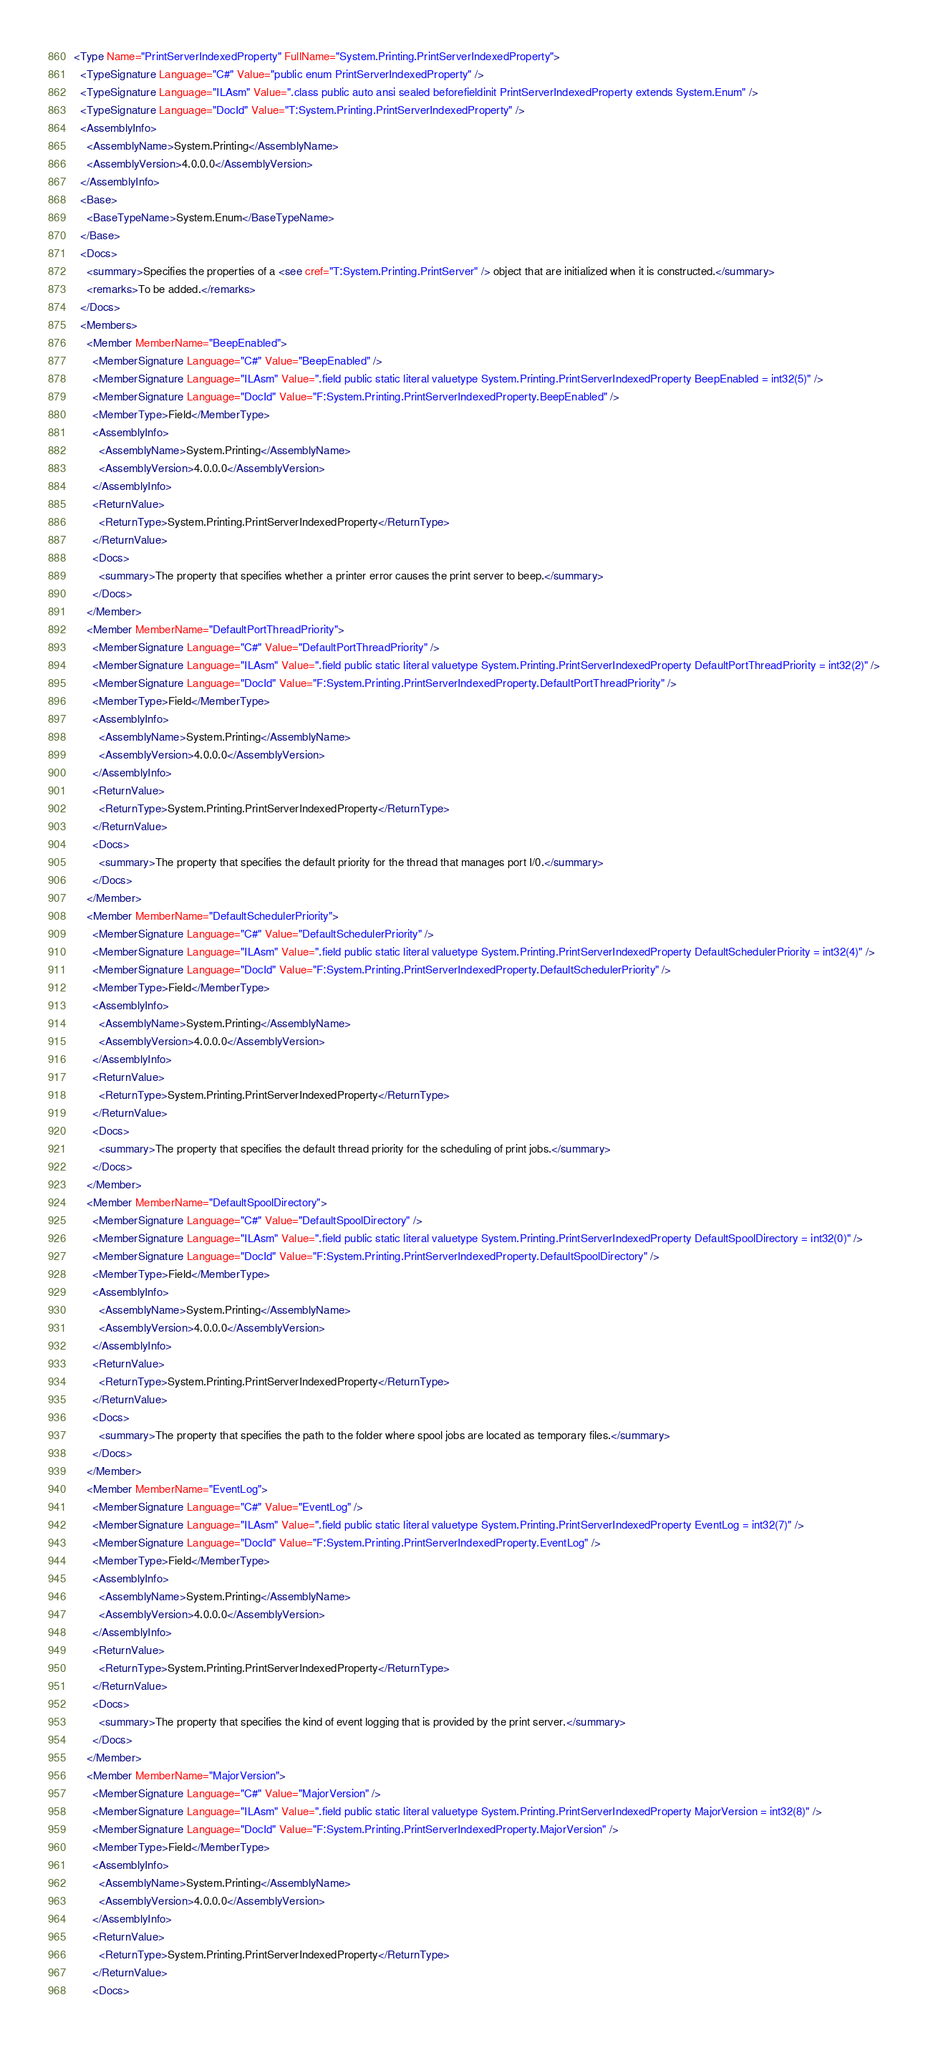Convert code to text. <code><loc_0><loc_0><loc_500><loc_500><_XML_><Type Name="PrintServerIndexedProperty" FullName="System.Printing.PrintServerIndexedProperty">
  <TypeSignature Language="C#" Value="public enum PrintServerIndexedProperty" />
  <TypeSignature Language="ILAsm" Value=".class public auto ansi sealed beforefieldinit PrintServerIndexedProperty extends System.Enum" />
  <TypeSignature Language="DocId" Value="T:System.Printing.PrintServerIndexedProperty" />
  <AssemblyInfo>
    <AssemblyName>System.Printing</AssemblyName>
    <AssemblyVersion>4.0.0.0</AssemblyVersion>
  </AssemblyInfo>
  <Base>
    <BaseTypeName>System.Enum</BaseTypeName>
  </Base>
  <Docs>
    <summary>Specifies the properties of a <see cref="T:System.Printing.PrintServer" /> object that are initialized when it is constructed.</summary>
    <remarks>To be added.</remarks>
  </Docs>
  <Members>
    <Member MemberName="BeepEnabled">
      <MemberSignature Language="C#" Value="BeepEnabled" />
      <MemberSignature Language="ILAsm" Value=".field public static literal valuetype System.Printing.PrintServerIndexedProperty BeepEnabled = int32(5)" />
      <MemberSignature Language="DocId" Value="F:System.Printing.PrintServerIndexedProperty.BeepEnabled" />
      <MemberType>Field</MemberType>
      <AssemblyInfo>
        <AssemblyName>System.Printing</AssemblyName>
        <AssemblyVersion>4.0.0.0</AssemblyVersion>
      </AssemblyInfo>
      <ReturnValue>
        <ReturnType>System.Printing.PrintServerIndexedProperty</ReturnType>
      </ReturnValue>
      <Docs>
        <summary>The property that specifies whether a printer error causes the print server to beep.</summary>
      </Docs>
    </Member>
    <Member MemberName="DefaultPortThreadPriority">
      <MemberSignature Language="C#" Value="DefaultPortThreadPriority" />
      <MemberSignature Language="ILAsm" Value=".field public static literal valuetype System.Printing.PrintServerIndexedProperty DefaultPortThreadPriority = int32(2)" />
      <MemberSignature Language="DocId" Value="F:System.Printing.PrintServerIndexedProperty.DefaultPortThreadPriority" />
      <MemberType>Field</MemberType>
      <AssemblyInfo>
        <AssemblyName>System.Printing</AssemblyName>
        <AssemblyVersion>4.0.0.0</AssemblyVersion>
      </AssemblyInfo>
      <ReturnValue>
        <ReturnType>System.Printing.PrintServerIndexedProperty</ReturnType>
      </ReturnValue>
      <Docs>
        <summary>The property that specifies the default priority for the thread that manages port I/0.</summary>
      </Docs>
    </Member>
    <Member MemberName="DefaultSchedulerPriority">
      <MemberSignature Language="C#" Value="DefaultSchedulerPriority" />
      <MemberSignature Language="ILAsm" Value=".field public static literal valuetype System.Printing.PrintServerIndexedProperty DefaultSchedulerPriority = int32(4)" />
      <MemberSignature Language="DocId" Value="F:System.Printing.PrintServerIndexedProperty.DefaultSchedulerPriority" />
      <MemberType>Field</MemberType>
      <AssemblyInfo>
        <AssemblyName>System.Printing</AssemblyName>
        <AssemblyVersion>4.0.0.0</AssemblyVersion>
      </AssemblyInfo>
      <ReturnValue>
        <ReturnType>System.Printing.PrintServerIndexedProperty</ReturnType>
      </ReturnValue>
      <Docs>
        <summary>The property that specifies the default thread priority for the scheduling of print jobs.</summary>
      </Docs>
    </Member>
    <Member MemberName="DefaultSpoolDirectory">
      <MemberSignature Language="C#" Value="DefaultSpoolDirectory" />
      <MemberSignature Language="ILAsm" Value=".field public static literal valuetype System.Printing.PrintServerIndexedProperty DefaultSpoolDirectory = int32(0)" />
      <MemberSignature Language="DocId" Value="F:System.Printing.PrintServerIndexedProperty.DefaultSpoolDirectory" />
      <MemberType>Field</MemberType>
      <AssemblyInfo>
        <AssemblyName>System.Printing</AssemblyName>
        <AssemblyVersion>4.0.0.0</AssemblyVersion>
      </AssemblyInfo>
      <ReturnValue>
        <ReturnType>System.Printing.PrintServerIndexedProperty</ReturnType>
      </ReturnValue>
      <Docs>
        <summary>The property that specifies the path to the folder where spool jobs are located as temporary files.</summary>
      </Docs>
    </Member>
    <Member MemberName="EventLog">
      <MemberSignature Language="C#" Value="EventLog" />
      <MemberSignature Language="ILAsm" Value=".field public static literal valuetype System.Printing.PrintServerIndexedProperty EventLog = int32(7)" />
      <MemberSignature Language="DocId" Value="F:System.Printing.PrintServerIndexedProperty.EventLog" />
      <MemberType>Field</MemberType>
      <AssemblyInfo>
        <AssemblyName>System.Printing</AssemblyName>
        <AssemblyVersion>4.0.0.0</AssemblyVersion>
      </AssemblyInfo>
      <ReturnValue>
        <ReturnType>System.Printing.PrintServerIndexedProperty</ReturnType>
      </ReturnValue>
      <Docs>
        <summary>The property that specifies the kind of event logging that is provided by the print server.</summary>
      </Docs>
    </Member>
    <Member MemberName="MajorVersion">
      <MemberSignature Language="C#" Value="MajorVersion" />
      <MemberSignature Language="ILAsm" Value=".field public static literal valuetype System.Printing.PrintServerIndexedProperty MajorVersion = int32(8)" />
      <MemberSignature Language="DocId" Value="F:System.Printing.PrintServerIndexedProperty.MajorVersion" />
      <MemberType>Field</MemberType>
      <AssemblyInfo>
        <AssemblyName>System.Printing</AssemblyName>
        <AssemblyVersion>4.0.0.0</AssemblyVersion>
      </AssemblyInfo>
      <ReturnValue>
        <ReturnType>System.Printing.PrintServerIndexedProperty</ReturnType>
      </ReturnValue>
      <Docs></code> 